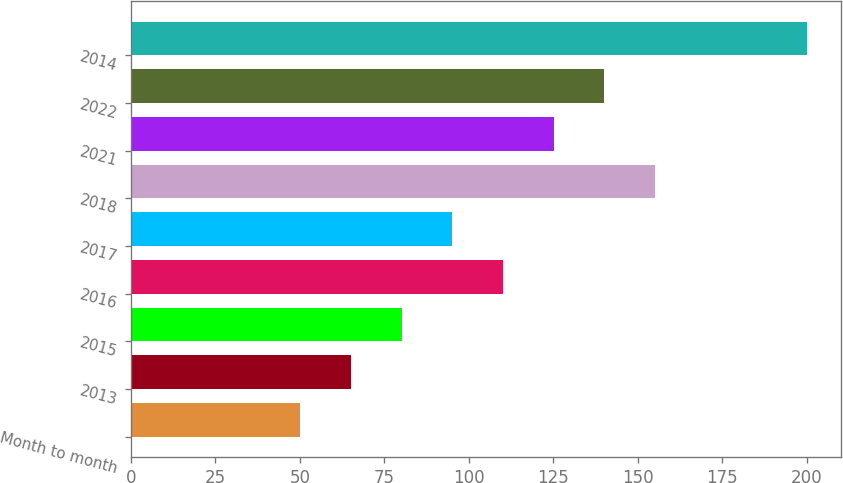Convert chart. <chart><loc_0><loc_0><loc_500><loc_500><bar_chart><fcel>Month to month<fcel>2013<fcel>2015<fcel>2016<fcel>2017<fcel>2018<fcel>2021<fcel>2022<fcel>2014<nl><fcel>50.16<fcel>65.14<fcel>80.12<fcel>110.08<fcel>95.1<fcel>155.02<fcel>125.06<fcel>140.04<fcel>199.94<nl></chart> 